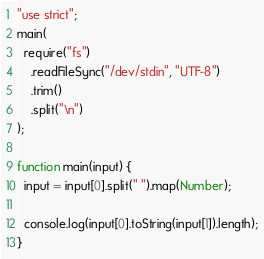Convert code to text. <code><loc_0><loc_0><loc_500><loc_500><_JavaScript_>"use strict";
main(
  require("fs")
    .readFileSync("/dev/stdin", "UTF-8")
    .trim()
    .split("\n")
);

function main(input) {
  input = input[0].split(" ").map(Number);

  console.log(input[0].toString(input[1]).length);
}
</code> 